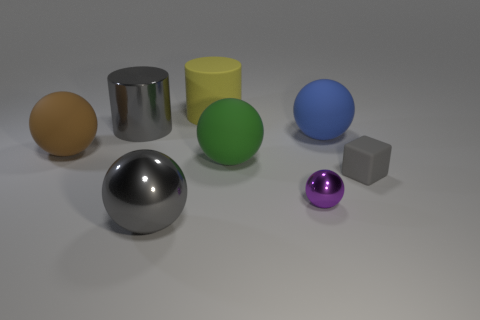Subtract all gray spheres. How many spheres are left? 4 Subtract all tiny metallic spheres. How many spheres are left? 4 Subtract 1 spheres. How many spheres are left? 4 Subtract all red spheres. Subtract all cyan cubes. How many spheres are left? 5 Add 2 big yellow rubber things. How many objects exist? 10 Subtract all blocks. How many objects are left? 7 Add 7 tiny metallic balls. How many tiny metallic balls exist? 8 Subtract 1 green spheres. How many objects are left? 7 Subtract all tiny rubber blocks. Subtract all large green objects. How many objects are left? 6 Add 4 tiny rubber objects. How many tiny rubber objects are left? 5 